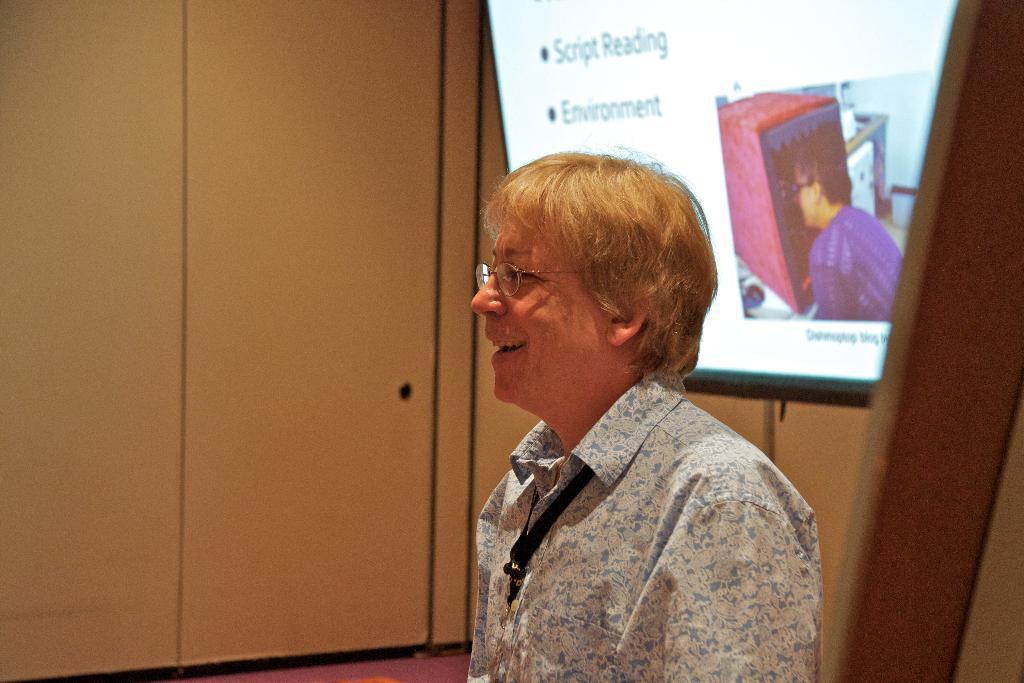How would you summarize this image in a sentence or two? In the picture I can see a person wearing shirt, identity card and spectacles is smiling. In the background, I can see the projector screen on which something is displayed and I can see the white color wall. Here I can see the wooden stick on the right side of the image. 